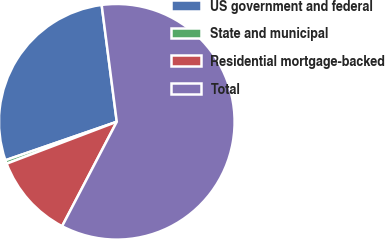<chart> <loc_0><loc_0><loc_500><loc_500><pie_chart><fcel>US government and federal<fcel>State and municipal<fcel>Residential mortgage-backed<fcel>Total<nl><fcel>28.25%<fcel>0.49%<fcel>11.54%<fcel>59.73%<nl></chart> 